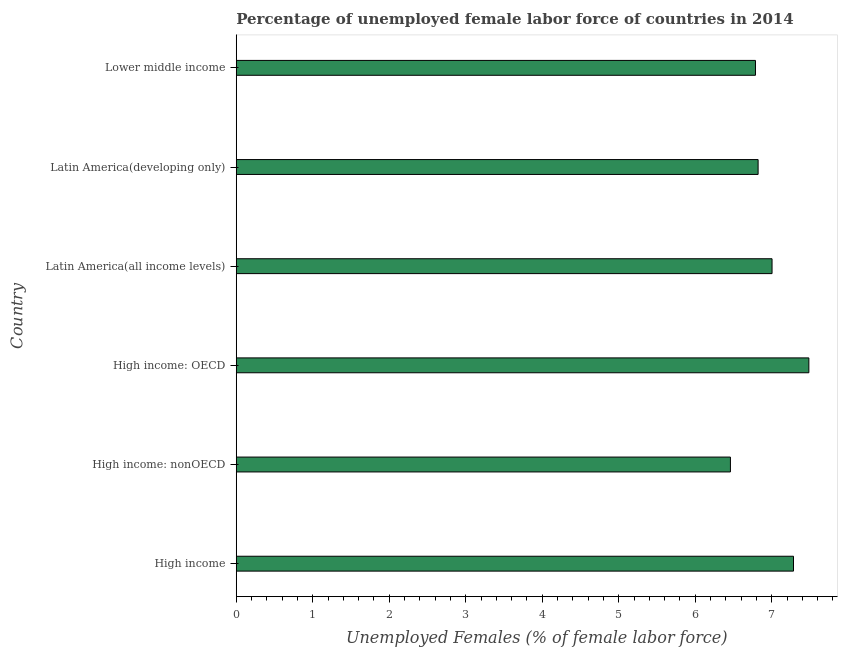What is the title of the graph?
Make the answer very short. Percentage of unemployed female labor force of countries in 2014. What is the label or title of the X-axis?
Offer a terse response. Unemployed Females (% of female labor force). What is the total unemployed female labour force in Latin America(developing only)?
Provide a short and direct response. 6.82. Across all countries, what is the maximum total unemployed female labour force?
Your answer should be very brief. 7.48. Across all countries, what is the minimum total unemployed female labour force?
Your answer should be very brief. 6.46. In which country was the total unemployed female labour force maximum?
Your answer should be compact. High income: OECD. In which country was the total unemployed female labour force minimum?
Keep it short and to the point. High income: nonOECD. What is the sum of the total unemployed female labour force?
Provide a succinct answer. 41.84. What is the difference between the total unemployed female labour force in High income and High income: OECD?
Ensure brevity in your answer.  -0.2. What is the average total unemployed female labour force per country?
Your response must be concise. 6.97. What is the median total unemployed female labour force?
Your response must be concise. 6.91. In how many countries, is the total unemployed female labour force greater than 0.6 %?
Make the answer very short. 6. What is the ratio of the total unemployed female labour force in High income: nonOECD to that in Latin America(developing only)?
Ensure brevity in your answer.  0.95. Is the total unemployed female labour force in High income less than that in Lower middle income?
Offer a very short reply. No. Is the difference between the total unemployed female labour force in High income: OECD and Latin America(developing only) greater than the difference between any two countries?
Offer a terse response. No. What is the difference between the highest and the second highest total unemployed female labour force?
Provide a short and direct response. 0.2. Is the sum of the total unemployed female labour force in High income: OECD and High income: nonOECD greater than the maximum total unemployed female labour force across all countries?
Provide a short and direct response. Yes. In how many countries, is the total unemployed female labour force greater than the average total unemployed female labour force taken over all countries?
Provide a short and direct response. 3. How many countries are there in the graph?
Offer a terse response. 6. What is the Unemployed Females (% of female labor force) in High income?
Give a very brief answer. 7.28. What is the Unemployed Females (% of female labor force) of High income: nonOECD?
Keep it short and to the point. 6.46. What is the Unemployed Females (% of female labor force) in High income: OECD?
Your answer should be compact. 7.48. What is the Unemployed Females (% of female labor force) of Latin America(all income levels)?
Offer a very short reply. 7. What is the Unemployed Females (% of female labor force) of Latin America(developing only)?
Your answer should be compact. 6.82. What is the Unemployed Females (% of female labor force) of Lower middle income?
Offer a very short reply. 6.79. What is the difference between the Unemployed Females (% of female labor force) in High income and High income: nonOECD?
Provide a short and direct response. 0.82. What is the difference between the Unemployed Females (% of female labor force) in High income and High income: OECD?
Provide a succinct answer. -0.2. What is the difference between the Unemployed Females (% of female labor force) in High income and Latin America(all income levels)?
Your answer should be compact. 0.28. What is the difference between the Unemployed Females (% of female labor force) in High income and Latin America(developing only)?
Keep it short and to the point. 0.46. What is the difference between the Unemployed Females (% of female labor force) in High income and Lower middle income?
Offer a terse response. 0.5. What is the difference between the Unemployed Females (% of female labor force) in High income: nonOECD and High income: OECD?
Ensure brevity in your answer.  -1.03. What is the difference between the Unemployed Females (% of female labor force) in High income: nonOECD and Latin America(all income levels)?
Make the answer very short. -0.54. What is the difference between the Unemployed Females (% of female labor force) in High income: nonOECD and Latin America(developing only)?
Ensure brevity in your answer.  -0.36. What is the difference between the Unemployed Females (% of female labor force) in High income: nonOECD and Lower middle income?
Provide a succinct answer. -0.33. What is the difference between the Unemployed Females (% of female labor force) in High income: OECD and Latin America(all income levels)?
Make the answer very short. 0.48. What is the difference between the Unemployed Females (% of female labor force) in High income: OECD and Latin America(developing only)?
Offer a very short reply. 0.66. What is the difference between the Unemployed Females (% of female labor force) in High income: OECD and Lower middle income?
Your answer should be compact. 0.7. What is the difference between the Unemployed Females (% of female labor force) in Latin America(all income levels) and Latin America(developing only)?
Offer a terse response. 0.18. What is the difference between the Unemployed Females (% of female labor force) in Latin America(all income levels) and Lower middle income?
Your response must be concise. 0.22. What is the difference between the Unemployed Females (% of female labor force) in Latin America(developing only) and Lower middle income?
Ensure brevity in your answer.  0.03. What is the ratio of the Unemployed Females (% of female labor force) in High income to that in High income: nonOECD?
Keep it short and to the point. 1.13. What is the ratio of the Unemployed Females (% of female labor force) in High income to that in High income: OECD?
Your response must be concise. 0.97. What is the ratio of the Unemployed Females (% of female labor force) in High income to that in Latin America(developing only)?
Provide a succinct answer. 1.07. What is the ratio of the Unemployed Females (% of female labor force) in High income to that in Lower middle income?
Your response must be concise. 1.07. What is the ratio of the Unemployed Females (% of female labor force) in High income: nonOECD to that in High income: OECD?
Give a very brief answer. 0.86. What is the ratio of the Unemployed Females (% of female labor force) in High income: nonOECD to that in Latin America(all income levels)?
Give a very brief answer. 0.92. What is the ratio of the Unemployed Females (% of female labor force) in High income: nonOECD to that in Latin America(developing only)?
Your answer should be very brief. 0.95. What is the ratio of the Unemployed Females (% of female labor force) in High income: OECD to that in Latin America(all income levels)?
Make the answer very short. 1.07. What is the ratio of the Unemployed Females (% of female labor force) in High income: OECD to that in Latin America(developing only)?
Make the answer very short. 1.1. What is the ratio of the Unemployed Females (% of female labor force) in High income: OECD to that in Lower middle income?
Make the answer very short. 1.1. What is the ratio of the Unemployed Females (% of female labor force) in Latin America(all income levels) to that in Lower middle income?
Provide a succinct answer. 1.03. What is the ratio of the Unemployed Females (% of female labor force) in Latin America(developing only) to that in Lower middle income?
Provide a short and direct response. 1. 